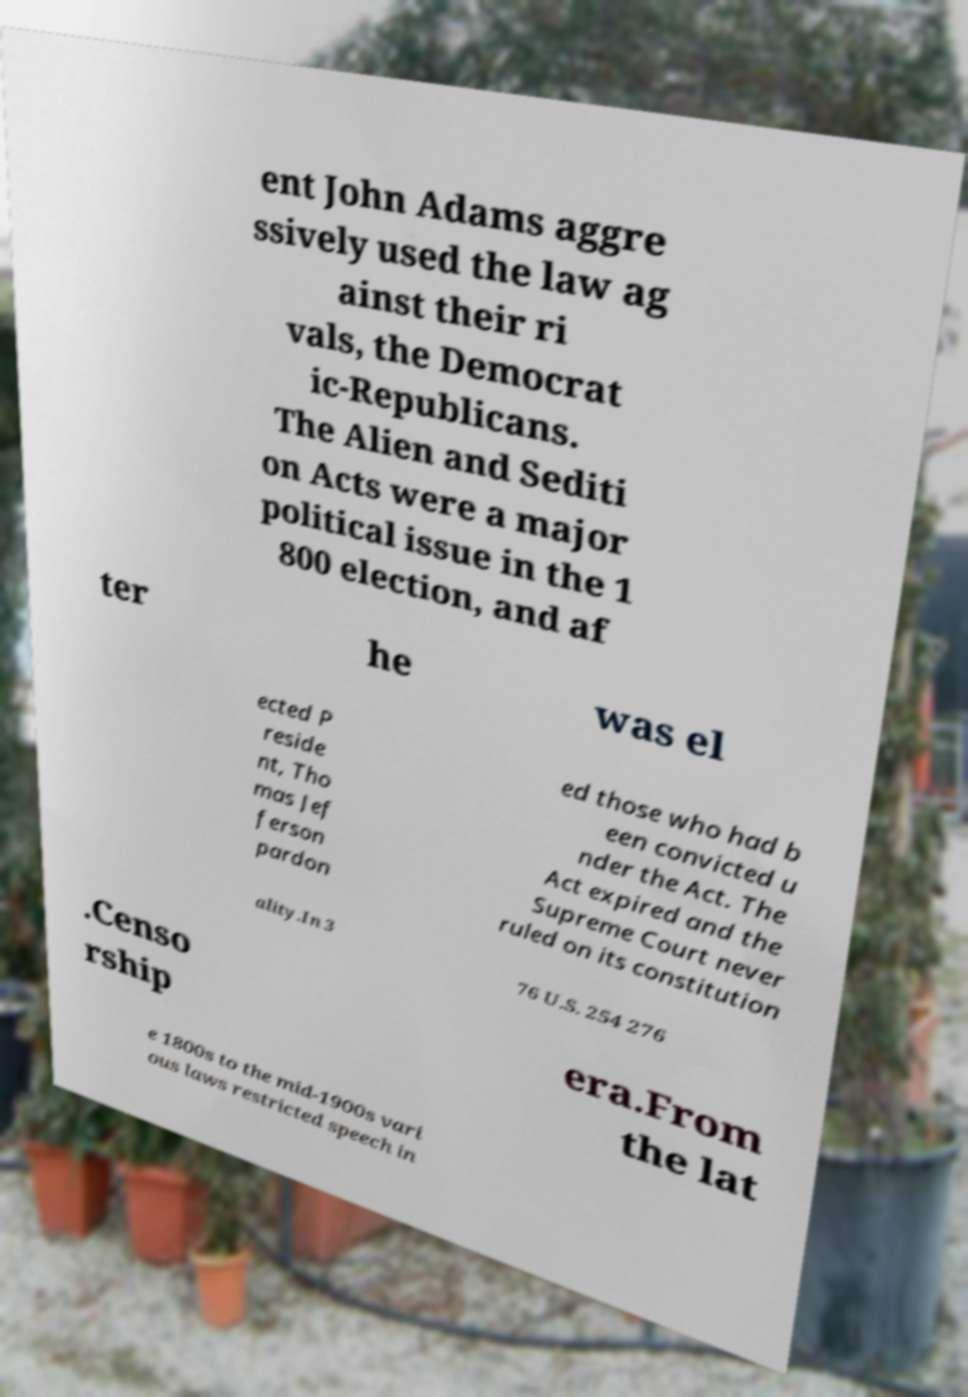What messages or text are displayed in this image? I need them in a readable, typed format. ent John Adams aggre ssively used the law ag ainst their ri vals, the Democrat ic-Republicans. The Alien and Sediti on Acts were a major political issue in the 1 800 election, and af ter he was el ected P reside nt, Tho mas Jef ferson pardon ed those who had b een convicted u nder the Act. The Act expired and the Supreme Court never ruled on its constitution ality.In 3 76 U.S. 254 276 .Censo rship era.From the lat e 1800s to the mid-1900s vari ous laws restricted speech in 